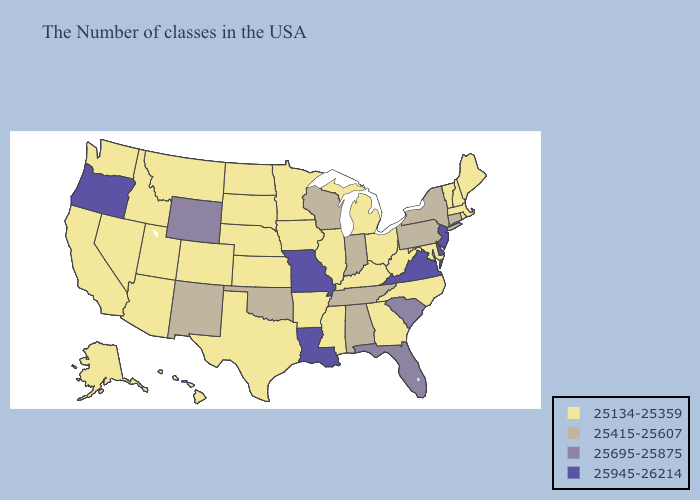What is the value of Illinois?
Short answer required. 25134-25359. What is the lowest value in the USA?
Be succinct. 25134-25359. Among the states that border Montana , does South Dakota have the highest value?
Quick response, please. No. What is the highest value in states that border Iowa?
Write a very short answer. 25945-26214. Name the states that have a value in the range 25415-25607?
Answer briefly. Connecticut, New York, Pennsylvania, Indiana, Alabama, Tennessee, Wisconsin, Oklahoma, New Mexico. Name the states that have a value in the range 25695-25875?
Concise answer only. South Carolina, Florida, Wyoming. What is the value of Idaho?
Give a very brief answer. 25134-25359. Does Wisconsin have the highest value in the MidWest?
Keep it brief. No. What is the value of Oregon?
Concise answer only. 25945-26214. Which states hav the highest value in the South?
Keep it brief. Delaware, Virginia, Louisiana. How many symbols are there in the legend?
Give a very brief answer. 4. Name the states that have a value in the range 25695-25875?
Keep it brief. South Carolina, Florida, Wyoming. Name the states that have a value in the range 25945-26214?
Answer briefly. New Jersey, Delaware, Virginia, Louisiana, Missouri, Oregon. Does Connecticut have the lowest value in the USA?
Be succinct. No. What is the lowest value in the West?
Answer briefly. 25134-25359. 